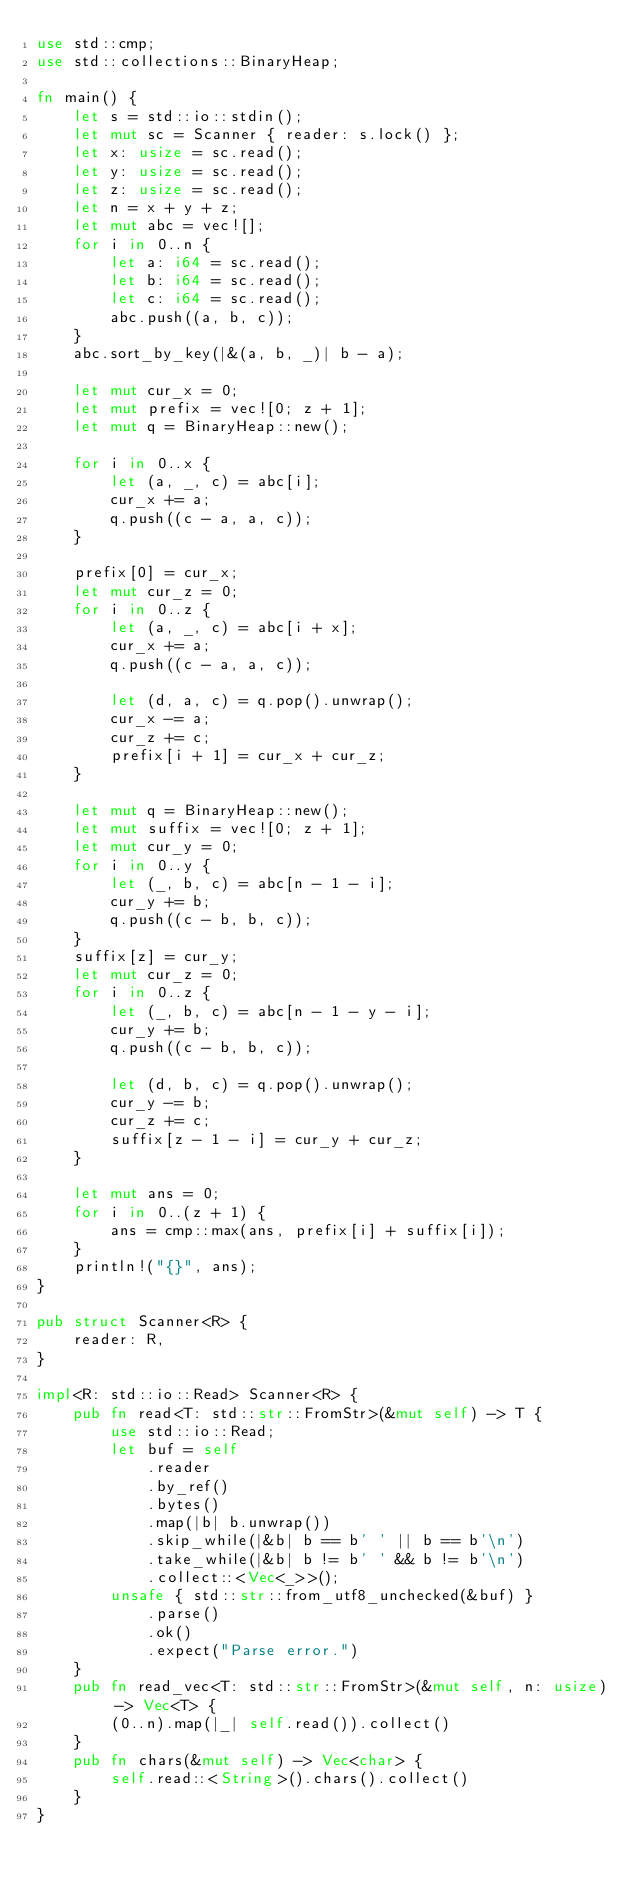<code> <loc_0><loc_0><loc_500><loc_500><_Rust_>use std::cmp;
use std::collections::BinaryHeap;

fn main() {
    let s = std::io::stdin();
    let mut sc = Scanner { reader: s.lock() };
    let x: usize = sc.read();
    let y: usize = sc.read();
    let z: usize = sc.read();
    let n = x + y + z;
    let mut abc = vec![];
    for i in 0..n {
        let a: i64 = sc.read();
        let b: i64 = sc.read();
        let c: i64 = sc.read();
        abc.push((a, b, c));
    }
    abc.sort_by_key(|&(a, b, _)| b - a);

    let mut cur_x = 0;
    let mut prefix = vec![0; z + 1];
    let mut q = BinaryHeap::new();

    for i in 0..x {
        let (a, _, c) = abc[i];
        cur_x += a;
        q.push((c - a, a, c));
    }

    prefix[0] = cur_x;
    let mut cur_z = 0;
    for i in 0..z {
        let (a, _, c) = abc[i + x];
        cur_x += a;
        q.push((c - a, a, c));

        let (d, a, c) = q.pop().unwrap();
        cur_x -= a;
        cur_z += c;
        prefix[i + 1] = cur_x + cur_z;
    }

    let mut q = BinaryHeap::new();
    let mut suffix = vec![0; z + 1];
    let mut cur_y = 0;
    for i in 0..y {
        let (_, b, c) = abc[n - 1 - i];
        cur_y += b;
        q.push((c - b, b, c));
    }
    suffix[z] = cur_y;
    let mut cur_z = 0;
    for i in 0..z {
        let (_, b, c) = abc[n - 1 - y - i];
        cur_y += b;
        q.push((c - b, b, c));

        let (d, b, c) = q.pop().unwrap();
        cur_y -= b;
        cur_z += c;
        suffix[z - 1 - i] = cur_y + cur_z;
    }

    let mut ans = 0;
    for i in 0..(z + 1) {
        ans = cmp::max(ans, prefix[i] + suffix[i]);
    }
    println!("{}", ans);
}

pub struct Scanner<R> {
    reader: R,
}

impl<R: std::io::Read> Scanner<R> {
    pub fn read<T: std::str::FromStr>(&mut self) -> T {
        use std::io::Read;
        let buf = self
            .reader
            .by_ref()
            .bytes()
            .map(|b| b.unwrap())
            .skip_while(|&b| b == b' ' || b == b'\n')
            .take_while(|&b| b != b' ' && b != b'\n')
            .collect::<Vec<_>>();
        unsafe { std::str::from_utf8_unchecked(&buf) }
            .parse()
            .ok()
            .expect("Parse error.")
    }
    pub fn read_vec<T: std::str::FromStr>(&mut self, n: usize) -> Vec<T> {
        (0..n).map(|_| self.read()).collect()
    }
    pub fn chars(&mut self) -> Vec<char> {
        self.read::<String>().chars().collect()
    }
}
</code> 